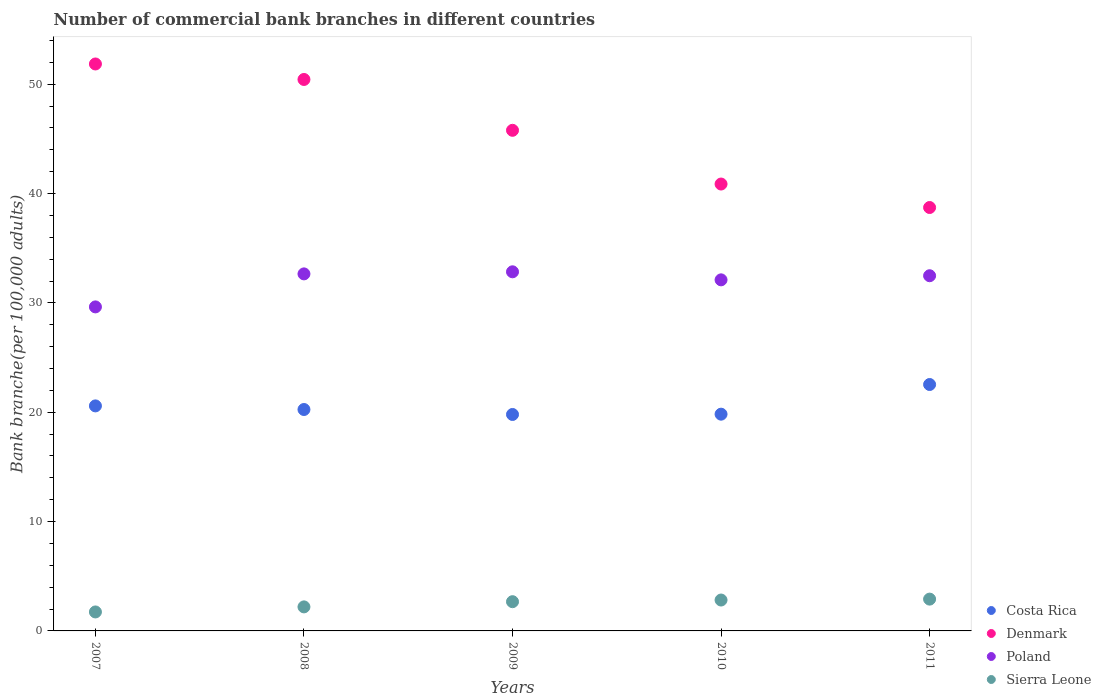What is the number of commercial bank branches in Poland in 2009?
Keep it short and to the point. 32.84. Across all years, what is the maximum number of commercial bank branches in Denmark?
Offer a terse response. 51.85. Across all years, what is the minimum number of commercial bank branches in Costa Rica?
Your answer should be very brief. 19.79. What is the total number of commercial bank branches in Poland in the graph?
Ensure brevity in your answer.  159.71. What is the difference between the number of commercial bank branches in Costa Rica in 2007 and that in 2011?
Offer a terse response. -1.96. What is the difference between the number of commercial bank branches in Denmark in 2008 and the number of commercial bank branches in Poland in 2009?
Give a very brief answer. 17.59. What is the average number of commercial bank branches in Costa Rica per year?
Your answer should be compact. 20.6. In the year 2009, what is the difference between the number of commercial bank branches in Costa Rica and number of commercial bank branches in Denmark?
Provide a short and direct response. -25.99. In how many years, is the number of commercial bank branches in Sierra Leone greater than 52?
Offer a terse response. 0. What is the ratio of the number of commercial bank branches in Poland in 2009 to that in 2010?
Make the answer very short. 1.02. Is the number of commercial bank branches in Costa Rica in 2007 less than that in 2011?
Your answer should be very brief. Yes. Is the difference between the number of commercial bank branches in Costa Rica in 2009 and 2011 greater than the difference between the number of commercial bank branches in Denmark in 2009 and 2011?
Offer a terse response. No. What is the difference between the highest and the second highest number of commercial bank branches in Poland?
Provide a short and direct response. 0.19. What is the difference between the highest and the lowest number of commercial bank branches in Sierra Leone?
Ensure brevity in your answer.  1.17. Is the sum of the number of commercial bank branches in Poland in 2007 and 2011 greater than the maximum number of commercial bank branches in Costa Rica across all years?
Keep it short and to the point. Yes. Is it the case that in every year, the sum of the number of commercial bank branches in Costa Rica and number of commercial bank branches in Sierra Leone  is greater than the sum of number of commercial bank branches in Poland and number of commercial bank branches in Denmark?
Offer a terse response. No. Does the number of commercial bank branches in Denmark monotonically increase over the years?
Give a very brief answer. No. Is the number of commercial bank branches in Poland strictly less than the number of commercial bank branches in Sierra Leone over the years?
Your answer should be very brief. No. How many dotlines are there?
Your answer should be compact. 4. What is the difference between two consecutive major ticks on the Y-axis?
Your answer should be very brief. 10. Are the values on the major ticks of Y-axis written in scientific E-notation?
Keep it short and to the point. No. Does the graph contain any zero values?
Provide a short and direct response. No. Does the graph contain grids?
Ensure brevity in your answer.  No. How are the legend labels stacked?
Ensure brevity in your answer.  Vertical. What is the title of the graph?
Provide a short and direct response. Number of commercial bank branches in different countries. What is the label or title of the X-axis?
Your answer should be very brief. Years. What is the label or title of the Y-axis?
Your answer should be compact. Bank branche(per 100,0 adults). What is the Bank branche(per 100,000 adults) in Costa Rica in 2007?
Ensure brevity in your answer.  20.58. What is the Bank branche(per 100,000 adults) of Denmark in 2007?
Offer a terse response. 51.85. What is the Bank branche(per 100,000 adults) of Poland in 2007?
Provide a succinct answer. 29.63. What is the Bank branche(per 100,000 adults) in Sierra Leone in 2007?
Provide a short and direct response. 1.73. What is the Bank branche(per 100,000 adults) in Costa Rica in 2008?
Make the answer very short. 20.25. What is the Bank branche(per 100,000 adults) in Denmark in 2008?
Offer a very short reply. 50.43. What is the Bank branche(per 100,000 adults) of Poland in 2008?
Give a very brief answer. 32.65. What is the Bank branche(per 100,000 adults) in Sierra Leone in 2008?
Make the answer very short. 2.2. What is the Bank branche(per 100,000 adults) in Costa Rica in 2009?
Offer a very short reply. 19.79. What is the Bank branche(per 100,000 adults) of Denmark in 2009?
Provide a succinct answer. 45.78. What is the Bank branche(per 100,000 adults) in Poland in 2009?
Your answer should be very brief. 32.84. What is the Bank branche(per 100,000 adults) in Sierra Leone in 2009?
Ensure brevity in your answer.  2.67. What is the Bank branche(per 100,000 adults) in Costa Rica in 2010?
Offer a very short reply. 19.82. What is the Bank branche(per 100,000 adults) in Denmark in 2010?
Your answer should be compact. 40.87. What is the Bank branche(per 100,000 adults) of Poland in 2010?
Ensure brevity in your answer.  32.11. What is the Bank branche(per 100,000 adults) of Sierra Leone in 2010?
Your answer should be compact. 2.83. What is the Bank branche(per 100,000 adults) of Costa Rica in 2011?
Make the answer very short. 22.53. What is the Bank branche(per 100,000 adults) of Denmark in 2011?
Keep it short and to the point. 38.72. What is the Bank branche(per 100,000 adults) in Poland in 2011?
Offer a terse response. 32.48. What is the Bank branche(per 100,000 adults) in Sierra Leone in 2011?
Your answer should be compact. 2.91. Across all years, what is the maximum Bank branche(per 100,000 adults) in Costa Rica?
Your response must be concise. 22.53. Across all years, what is the maximum Bank branche(per 100,000 adults) of Denmark?
Your answer should be very brief. 51.85. Across all years, what is the maximum Bank branche(per 100,000 adults) of Poland?
Your answer should be very brief. 32.84. Across all years, what is the maximum Bank branche(per 100,000 adults) in Sierra Leone?
Offer a terse response. 2.91. Across all years, what is the minimum Bank branche(per 100,000 adults) of Costa Rica?
Offer a very short reply. 19.79. Across all years, what is the minimum Bank branche(per 100,000 adults) of Denmark?
Ensure brevity in your answer.  38.72. Across all years, what is the minimum Bank branche(per 100,000 adults) in Poland?
Your response must be concise. 29.63. Across all years, what is the minimum Bank branche(per 100,000 adults) in Sierra Leone?
Provide a succinct answer. 1.73. What is the total Bank branche(per 100,000 adults) in Costa Rica in the graph?
Offer a very short reply. 102.98. What is the total Bank branche(per 100,000 adults) in Denmark in the graph?
Your answer should be compact. 227.65. What is the total Bank branche(per 100,000 adults) in Poland in the graph?
Provide a short and direct response. 159.71. What is the total Bank branche(per 100,000 adults) in Sierra Leone in the graph?
Offer a terse response. 12.34. What is the difference between the Bank branche(per 100,000 adults) in Costa Rica in 2007 and that in 2008?
Keep it short and to the point. 0.33. What is the difference between the Bank branche(per 100,000 adults) in Denmark in 2007 and that in 2008?
Make the answer very short. 1.42. What is the difference between the Bank branche(per 100,000 adults) of Poland in 2007 and that in 2008?
Your response must be concise. -3.02. What is the difference between the Bank branche(per 100,000 adults) in Sierra Leone in 2007 and that in 2008?
Give a very brief answer. -0.46. What is the difference between the Bank branche(per 100,000 adults) in Costa Rica in 2007 and that in 2009?
Your response must be concise. 0.78. What is the difference between the Bank branche(per 100,000 adults) of Denmark in 2007 and that in 2009?
Your answer should be compact. 6.07. What is the difference between the Bank branche(per 100,000 adults) in Poland in 2007 and that in 2009?
Your response must be concise. -3.21. What is the difference between the Bank branche(per 100,000 adults) in Sierra Leone in 2007 and that in 2009?
Your answer should be very brief. -0.94. What is the difference between the Bank branche(per 100,000 adults) in Costa Rica in 2007 and that in 2010?
Give a very brief answer. 0.76. What is the difference between the Bank branche(per 100,000 adults) of Denmark in 2007 and that in 2010?
Make the answer very short. 10.98. What is the difference between the Bank branche(per 100,000 adults) of Poland in 2007 and that in 2010?
Provide a short and direct response. -2.47. What is the difference between the Bank branche(per 100,000 adults) of Sierra Leone in 2007 and that in 2010?
Offer a very short reply. -1.09. What is the difference between the Bank branche(per 100,000 adults) in Costa Rica in 2007 and that in 2011?
Provide a succinct answer. -1.96. What is the difference between the Bank branche(per 100,000 adults) in Denmark in 2007 and that in 2011?
Provide a short and direct response. 13.13. What is the difference between the Bank branche(per 100,000 adults) of Poland in 2007 and that in 2011?
Ensure brevity in your answer.  -2.85. What is the difference between the Bank branche(per 100,000 adults) in Sierra Leone in 2007 and that in 2011?
Keep it short and to the point. -1.17. What is the difference between the Bank branche(per 100,000 adults) of Costa Rica in 2008 and that in 2009?
Your response must be concise. 0.45. What is the difference between the Bank branche(per 100,000 adults) of Denmark in 2008 and that in 2009?
Offer a terse response. 4.65. What is the difference between the Bank branche(per 100,000 adults) of Poland in 2008 and that in 2009?
Your answer should be compact. -0.19. What is the difference between the Bank branche(per 100,000 adults) in Sierra Leone in 2008 and that in 2009?
Keep it short and to the point. -0.48. What is the difference between the Bank branche(per 100,000 adults) of Costa Rica in 2008 and that in 2010?
Provide a short and direct response. 0.43. What is the difference between the Bank branche(per 100,000 adults) in Denmark in 2008 and that in 2010?
Give a very brief answer. 9.56. What is the difference between the Bank branche(per 100,000 adults) in Poland in 2008 and that in 2010?
Your answer should be compact. 0.54. What is the difference between the Bank branche(per 100,000 adults) of Sierra Leone in 2008 and that in 2010?
Make the answer very short. -0.63. What is the difference between the Bank branche(per 100,000 adults) in Costa Rica in 2008 and that in 2011?
Provide a succinct answer. -2.29. What is the difference between the Bank branche(per 100,000 adults) of Denmark in 2008 and that in 2011?
Ensure brevity in your answer.  11.71. What is the difference between the Bank branche(per 100,000 adults) in Poland in 2008 and that in 2011?
Ensure brevity in your answer.  0.17. What is the difference between the Bank branche(per 100,000 adults) of Sierra Leone in 2008 and that in 2011?
Provide a succinct answer. -0.71. What is the difference between the Bank branche(per 100,000 adults) of Costa Rica in 2009 and that in 2010?
Provide a succinct answer. -0.03. What is the difference between the Bank branche(per 100,000 adults) in Denmark in 2009 and that in 2010?
Provide a short and direct response. 4.91. What is the difference between the Bank branche(per 100,000 adults) of Poland in 2009 and that in 2010?
Your answer should be very brief. 0.74. What is the difference between the Bank branche(per 100,000 adults) in Sierra Leone in 2009 and that in 2010?
Offer a very short reply. -0.15. What is the difference between the Bank branche(per 100,000 adults) in Costa Rica in 2009 and that in 2011?
Provide a succinct answer. -2.74. What is the difference between the Bank branche(per 100,000 adults) in Denmark in 2009 and that in 2011?
Make the answer very short. 7.06. What is the difference between the Bank branche(per 100,000 adults) of Poland in 2009 and that in 2011?
Give a very brief answer. 0.36. What is the difference between the Bank branche(per 100,000 adults) in Sierra Leone in 2009 and that in 2011?
Ensure brevity in your answer.  -0.23. What is the difference between the Bank branche(per 100,000 adults) of Costa Rica in 2010 and that in 2011?
Provide a short and direct response. -2.71. What is the difference between the Bank branche(per 100,000 adults) of Denmark in 2010 and that in 2011?
Ensure brevity in your answer.  2.15. What is the difference between the Bank branche(per 100,000 adults) of Poland in 2010 and that in 2011?
Make the answer very short. -0.38. What is the difference between the Bank branche(per 100,000 adults) of Sierra Leone in 2010 and that in 2011?
Your answer should be very brief. -0.08. What is the difference between the Bank branche(per 100,000 adults) in Costa Rica in 2007 and the Bank branche(per 100,000 adults) in Denmark in 2008?
Provide a short and direct response. -29.85. What is the difference between the Bank branche(per 100,000 adults) in Costa Rica in 2007 and the Bank branche(per 100,000 adults) in Poland in 2008?
Your answer should be compact. -12.07. What is the difference between the Bank branche(per 100,000 adults) in Costa Rica in 2007 and the Bank branche(per 100,000 adults) in Sierra Leone in 2008?
Give a very brief answer. 18.38. What is the difference between the Bank branche(per 100,000 adults) in Denmark in 2007 and the Bank branche(per 100,000 adults) in Poland in 2008?
Your response must be concise. 19.2. What is the difference between the Bank branche(per 100,000 adults) of Denmark in 2007 and the Bank branche(per 100,000 adults) of Sierra Leone in 2008?
Keep it short and to the point. 49.65. What is the difference between the Bank branche(per 100,000 adults) in Poland in 2007 and the Bank branche(per 100,000 adults) in Sierra Leone in 2008?
Offer a very short reply. 27.43. What is the difference between the Bank branche(per 100,000 adults) in Costa Rica in 2007 and the Bank branche(per 100,000 adults) in Denmark in 2009?
Make the answer very short. -25.2. What is the difference between the Bank branche(per 100,000 adults) in Costa Rica in 2007 and the Bank branche(per 100,000 adults) in Poland in 2009?
Provide a short and direct response. -12.26. What is the difference between the Bank branche(per 100,000 adults) in Costa Rica in 2007 and the Bank branche(per 100,000 adults) in Sierra Leone in 2009?
Keep it short and to the point. 17.91. What is the difference between the Bank branche(per 100,000 adults) in Denmark in 2007 and the Bank branche(per 100,000 adults) in Poland in 2009?
Ensure brevity in your answer.  19.01. What is the difference between the Bank branche(per 100,000 adults) in Denmark in 2007 and the Bank branche(per 100,000 adults) in Sierra Leone in 2009?
Make the answer very short. 49.18. What is the difference between the Bank branche(per 100,000 adults) of Poland in 2007 and the Bank branche(per 100,000 adults) of Sierra Leone in 2009?
Ensure brevity in your answer.  26.96. What is the difference between the Bank branche(per 100,000 adults) in Costa Rica in 2007 and the Bank branche(per 100,000 adults) in Denmark in 2010?
Provide a short and direct response. -20.29. What is the difference between the Bank branche(per 100,000 adults) in Costa Rica in 2007 and the Bank branche(per 100,000 adults) in Poland in 2010?
Your answer should be very brief. -11.53. What is the difference between the Bank branche(per 100,000 adults) of Costa Rica in 2007 and the Bank branche(per 100,000 adults) of Sierra Leone in 2010?
Your response must be concise. 17.75. What is the difference between the Bank branche(per 100,000 adults) in Denmark in 2007 and the Bank branche(per 100,000 adults) in Poland in 2010?
Your answer should be very brief. 19.74. What is the difference between the Bank branche(per 100,000 adults) of Denmark in 2007 and the Bank branche(per 100,000 adults) of Sierra Leone in 2010?
Provide a short and direct response. 49.02. What is the difference between the Bank branche(per 100,000 adults) of Poland in 2007 and the Bank branche(per 100,000 adults) of Sierra Leone in 2010?
Your response must be concise. 26.81. What is the difference between the Bank branche(per 100,000 adults) in Costa Rica in 2007 and the Bank branche(per 100,000 adults) in Denmark in 2011?
Your answer should be compact. -18.14. What is the difference between the Bank branche(per 100,000 adults) of Costa Rica in 2007 and the Bank branche(per 100,000 adults) of Poland in 2011?
Your response must be concise. -11.9. What is the difference between the Bank branche(per 100,000 adults) of Costa Rica in 2007 and the Bank branche(per 100,000 adults) of Sierra Leone in 2011?
Give a very brief answer. 17.67. What is the difference between the Bank branche(per 100,000 adults) of Denmark in 2007 and the Bank branche(per 100,000 adults) of Poland in 2011?
Make the answer very short. 19.37. What is the difference between the Bank branche(per 100,000 adults) of Denmark in 2007 and the Bank branche(per 100,000 adults) of Sierra Leone in 2011?
Make the answer very short. 48.94. What is the difference between the Bank branche(per 100,000 adults) in Poland in 2007 and the Bank branche(per 100,000 adults) in Sierra Leone in 2011?
Your answer should be very brief. 26.72. What is the difference between the Bank branche(per 100,000 adults) of Costa Rica in 2008 and the Bank branche(per 100,000 adults) of Denmark in 2009?
Your answer should be compact. -25.53. What is the difference between the Bank branche(per 100,000 adults) in Costa Rica in 2008 and the Bank branche(per 100,000 adults) in Poland in 2009?
Provide a succinct answer. -12.59. What is the difference between the Bank branche(per 100,000 adults) of Costa Rica in 2008 and the Bank branche(per 100,000 adults) of Sierra Leone in 2009?
Offer a terse response. 17.58. What is the difference between the Bank branche(per 100,000 adults) of Denmark in 2008 and the Bank branche(per 100,000 adults) of Poland in 2009?
Your answer should be very brief. 17.59. What is the difference between the Bank branche(per 100,000 adults) in Denmark in 2008 and the Bank branche(per 100,000 adults) in Sierra Leone in 2009?
Provide a succinct answer. 47.76. What is the difference between the Bank branche(per 100,000 adults) of Poland in 2008 and the Bank branche(per 100,000 adults) of Sierra Leone in 2009?
Offer a terse response. 29.98. What is the difference between the Bank branche(per 100,000 adults) in Costa Rica in 2008 and the Bank branche(per 100,000 adults) in Denmark in 2010?
Provide a short and direct response. -20.62. What is the difference between the Bank branche(per 100,000 adults) in Costa Rica in 2008 and the Bank branche(per 100,000 adults) in Poland in 2010?
Make the answer very short. -11.86. What is the difference between the Bank branche(per 100,000 adults) in Costa Rica in 2008 and the Bank branche(per 100,000 adults) in Sierra Leone in 2010?
Make the answer very short. 17.42. What is the difference between the Bank branche(per 100,000 adults) in Denmark in 2008 and the Bank branche(per 100,000 adults) in Poland in 2010?
Offer a terse response. 18.33. What is the difference between the Bank branche(per 100,000 adults) in Denmark in 2008 and the Bank branche(per 100,000 adults) in Sierra Leone in 2010?
Your answer should be very brief. 47.61. What is the difference between the Bank branche(per 100,000 adults) in Poland in 2008 and the Bank branche(per 100,000 adults) in Sierra Leone in 2010?
Offer a terse response. 29.83. What is the difference between the Bank branche(per 100,000 adults) in Costa Rica in 2008 and the Bank branche(per 100,000 adults) in Denmark in 2011?
Provide a short and direct response. -18.47. What is the difference between the Bank branche(per 100,000 adults) in Costa Rica in 2008 and the Bank branche(per 100,000 adults) in Poland in 2011?
Provide a short and direct response. -12.23. What is the difference between the Bank branche(per 100,000 adults) of Costa Rica in 2008 and the Bank branche(per 100,000 adults) of Sierra Leone in 2011?
Provide a short and direct response. 17.34. What is the difference between the Bank branche(per 100,000 adults) in Denmark in 2008 and the Bank branche(per 100,000 adults) in Poland in 2011?
Provide a succinct answer. 17.95. What is the difference between the Bank branche(per 100,000 adults) of Denmark in 2008 and the Bank branche(per 100,000 adults) of Sierra Leone in 2011?
Offer a terse response. 47.52. What is the difference between the Bank branche(per 100,000 adults) of Poland in 2008 and the Bank branche(per 100,000 adults) of Sierra Leone in 2011?
Ensure brevity in your answer.  29.74. What is the difference between the Bank branche(per 100,000 adults) in Costa Rica in 2009 and the Bank branche(per 100,000 adults) in Denmark in 2010?
Keep it short and to the point. -21.07. What is the difference between the Bank branche(per 100,000 adults) in Costa Rica in 2009 and the Bank branche(per 100,000 adults) in Poland in 2010?
Offer a terse response. -12.31. What is the difference between the Bank branche(per 100,000 adults) in Costa Rica in 2009 and the Bank branche(per 100,000 adults) in Sierra Leone in 2010?
Ensure brevity in your answer.  16.97. What is the difference between the Bank branche(per 100,000 adults) in Denmark in 2009 and the Bank branche(per 100,000 adults) in Poland in 2010?
Make the answer very short. 13.68. What is the difference between the Bank branche(per 100,000 adults) in Denmark in 2009 and the Bank branche(per 100,000 adults) in Sierra Leone in 2010?
Your answer should be very brief. 42.96. What is the difference between the Bank branche(per 100,000 adults) of Poland in 2009 and the Bank branche(per 100,000 adults) of Sierra Leone in 2010?
Provide a short and direct response. 30.02. What is the difference between the Bank branche(per 100,000 adults) of Costa Rica in 2009 and the Bank branche(per 100,000 adults) of Denmark in 2011?
Your answer should be compact. -18.93. What is the difference between the Bank branche(per 100,000 adults) in Costa Rica in 2009 and the Bank branche(per 100,000 adults) in Poland in 2011?
Your answer should be compact. -12.69. What is the difference between the Bank branche(per 100,000 adults) in Costa Rica in 2009 and the Bank branche(per 100,000 adults) in Sierra Leone in 2011?
Provide a succinct answer. 16.89. What is the difference between the Bank branche(per 100,000 adults) of Denmark in 2009 and the Bank branche(per 100,000 adults) of Poland in 2011?
Offer a terse response. 13.3. What is the difference between the Bank branche(per 100,000 adults) of Denmark in 2009 and the Bank branche(per 100,000 adults) of Sierra Leone in 2011?
Provide a succinct answer. 42.87. What is the difference between the Bank branche(per 100,000 adults) of Poland in 2009 and the Bank branche(per 100,000 adults) of Sierra Leone in 2011?
Offer a very short reply. 29.93. What is the difference between the Bank branche(per 100,000 adults) of Costa Rica in 2010 and the Bank branche(per 100,000 adults) of Denmark in 2011?
Give a very brief answer. -18.9. What is the difference between the Bank branche(per 100,000 adults) of Costa Rica in 2010 and the Bank branche(per 100,000 adults) of Poland in 2011?
Your response must be concise. -12.66. What is the difference between the Bank branche(per 100,000 adults) of Costa Rica in 2010 and the Bank branche(per 100,000 adults) of Sierra Leone in 2011?
Provide a short and direct response. 16.91. What is the difference between the Bank branche(per 100,000 adults) of Denmark in 2010 and the Bank branche(per 100,000 adults) of Poland in 2011?
Ensure brevity in your answer.  8.39. What is the difference between the Bank branche(per 100,000 adults) of Denmark in 2010 and the Bank branche(per 100,000 adults) of Sierra Leone in 2011?
Your answer should be compact. 37.96. What is the difference between the Bank branche(per 100,000 adults) in Poland in 2010 and the Bank branche(per 100,000 adults) in Sierra Leone in 2011?
Offer a terse response. 29.2. What is the average Bank branche(per 100,000 adults) of Costa Rica per year?
Provide a short and direct response. 20.6. What is the average Bank branche(per 100,000 adults) of Denmark per year?
Make the answer very short. 45.53. What is the average Bank branche(per 100,000 adults) in Poland per year?
Make the answer very short. 31.94. What is the average Bank branche(per 100,000 adults) of Sierra Leone per year?
Provide a short and direct response. 2.47. In the year 2007, what is the difference between the Bank branche(per 100,000 adults) in Costa Rica and Bank branche(per 100,000 adults) in Denmark?
Provide a short and direct response. -31.27. In the year 2007, what is the difference between the Bank branche(per 100,000 adults) in Costa Rica and Bank branche(per 100,000 adults) in Poland?
Ensure brevity in your answer.  -9.05. In the year 2007, what is the difference between the Bank branche(per 100,000 adults) of Costa Rica and Bank branche(per 100,000 adults) of Sierra Leone?
Provide a succinct answer. 18.84. In the year 2007, what is the difference between the Bank branche(per 100,000 adults) in Denmark and Bank branche(per 100,000 adults) in Poland?
Your response must be concise. 22.22. In the year 2007, what is the difference between the Bank branche(per 100,000 adults) in Denmark and Bank branche(per 100,000 adults) in Sierra Leone?
Offer a very short reply. 50.11. In the year 2007, what is the difference between the Bank branche(per 100,000 adults) of Poland and Bank branche(per 100,000 adults) of Sierra Leone?
Provide a succinct answer. 27.9. In the year 2008, what is the difference between the Bank branche(per 100,000 adults) of Costa Rica and Bank branche(per 100,000 adults) of Denmark?
Offer a very short reply. -30.18. In the year 2008, what is the difference between the Bank branche(per 100,000 adults) of Costa Rica and Bank branche(per 100,000 adults) of Poland?
Provide a succinct answer. -12.4. In the year 2008, what is the difference between the Bank branche(per 100,000 adults) in Costa Rica and Bank branche(per 100,000 adults) in Sierra Leone?
Keep it short and to the point. 18.05. In the year 2008, what is the difference between the Bank branche(per 100,000 adults) of Denmark and Bank branche(per 100,000 adults) of Poland?
Offer a very short reply. 17.78. In the year 2008, what is the difference between the Bank branche(per 100,000 adults) in Denmark and Bank branche(per 100,000 adults) in Sierra Leone?
Keep it short and to the point. 48.23. In the year 2008, what is the difference between the Bank branche(per 100,000 adults) of Poland and Bank branche(per 100,000 adults) of Sierra Leone?
Give a very brief answer. 30.45. In the year 2009, what is the difference between the Bank branche(per 100,000 adults) of Costa Rica and Bank branche(per 100,000 adults) of Denmark?
Give a very brief answer. -25.99. In the year 2009, what is the difference between the Bank branche(per 100,000 adults) of Costa Rica and Bank branche(per 100,000 adults) of Poland?
Ensure brevity in your answer.  -13.05. In the year 2009, what is the difference between the Bank branche(per 100,000 adults) in Costa Rica and Bank branche(per 100,000 adults) in Sierra Leone?
Keep it short and to the point. 17.12. In the year 2009, what is the difference between the Bank branche(per 100,000 adults) of Denmark and Bank branche(per 100,000 adults) of Poland?
Keep it short and to the point. 12.94. In the year 2009, what is the difference between the Bank branche(per 100,000 adults) of Denmark and Bank branche(per 100,000 adults) of Sierra Leone?
Make the answer very short. 43.11. In the year 2009, what is the difference between the Bank branche(per 100,000 adults) in Poland and Bank branche(per 100,000 adults) in Sierra Leone?
Keep it short and to the point. 30.17. In the year 2010, what is the difference between the Bank branche(per 100,000 adults) in Costa Rica and Bank branche(per 100,000 adults) in Denmark?
Offer a very short reply. -21.05. In the year 2010, what is the difference between the Bank branche(per 100,000 adults) in Costa Rica and Bank branche(per 100,000 adults) in Poland?
Provide a succinct answer. -12.28. In the year 2010, what is the difference between the Bank branche(per 100,000 adults) of Costa Rica and Bank branche(per 100,000 adults) of Sierra Leone?
Your answer should be compact. 17. In the year 2010, what is the difference between the Bank branche(per 100,000 adults) in Denmark and Bank branche(per 100,000 adults) in Poland?
Keep it short and to the point. 8.76. In the year 2010, what is the difference between the Bank branche(per 100,000 adults) of Denmark and Bank branche(per 100,000 adults) of Sierra Leone?
Your response must be concise. 38.04. In the year 2010, what is the difference between the Bank branche(per 100,000 adults) of Poland and Bank branche(per 100,000 adults) of Sierra Leone?
Your answer should be very brief. 29.28. In the year 2011, what is the difference between the Bank branche(per 100,000 adults) in Costa Rica and Bank branche(per 100,000 adults) in Denmark?
Provide a succinct answer. -16.19. In the year 2011, what is the difference between the Bank branche(per 100,000 adults) of Costa Rica and Bank branche(per 100,000 adults) of Poland?
Give a very brief answer. -9.95. In the year 2011, what is the difference between the Bank branche(per 100,000 adults) of Costa Rica and Bank branche(per 100,000 adults) of Sierra Leone?
Keep it short and to the point. 19.63. In the year 2011, what is the difference between the Bank branche(per 100,000 adults) of Denmark and Bank branche(per 100,000 adults) of Poland?
Offer a terse response. 6.24. In the year 2011, what is the difference between the Bank branche(per 100,000 adults) in Denmark and Bank branche(per 100,000 adults) in Sierra Leone?
Your answer should be very brief. 35.81. In the year 2011, what is the difference between the Bank branche(per 100,000 adults) of Poland and Bank branche(per 100,000 adults) of Sierra Leone?
Give a very brief answer. 29.57. What is the ratio of the Bank branche(per 100,000 adults) of Costa Rica in 2007 to that in 2008?
Make the answer very short. 1.02. What is the ratio of the Bank branche(per 100,000 adults) of Denmark in 2007 to that in 2008?
Ensure brevity in your answer.  1.03. What is the ratio of the Bank branche(per 100,000 adults) of Poland in 2007 to that in 2008?
Provide a short and direct response. 0.91. What is the ratio of the Bank branche(per 100,000 adults) in Sierra Leone in 2007 to that in 2008?
Offer a very short reply. 0.79. What is the ratio of the Bank branche(per 100,000 adults) in Costa Rica in 2007 to that in 2009?
Give a very brief answer. 1.04. What is the ratio of the Bank branche(per 100,000 adults) of Denmark in 2007 to that in 2009?
Give a very brief answer. 1.13. What is the ratio of the Bank branche(per 100,000 adults) in Poland in 2007 to that in 2009?
Give a very brief answer. 0.9. What is the ratio of the Bank branche(per 100,000 adults) of Sierra Leone in 2007 to that in 2009?
Make the answer very short. 0.65. What is the ratio of the Bank branche(per 100,000 adults) in Costa Rica in 2007 to that in 2010?
Your answer should be very brief. 1.04. What is the ratio of the Bank branche(per 100,000 adults) of Denmark in 2007 to that in 2010?
Offer a very short reply. 1.27. What is the ratio of the Bank branche(per 100,000 adults) in Poland in 2007 to that in 2010?
Your answer should be very brief. 0.92. What is the ratio of the Bank branche(per 100,000 adults) in Sierra Leone in 2007 to that in 2010?
Offer a very short reply. 0.61. What is the ratio of the Bank branche(per 100,000 adults) of Costa Rica in 2007 to that in 2011?
Your answer should be compact. 0.91. What is the ratio of the Bank branche(per 100,000 adults) of Denmark in 2007 to that in 2011?
Your answer should be compact. 1.34. What is the ratio of the Bank branche(per 100,000 adults) of Poland in 2007 to that in 2011?
Your answer should be compact. 0.91. What is the ratio of the Bank branche(per 100,000 adults) of Sierra Leone in 2007 to that in 2011?
Give a very brief answer. 0.6. What is the ratio of the Bank branche(per 100,000 adults) in Denmark in 2008 to that in 2009?
Offer a very short reply. 1.1. What is the ratio of the Bank branche(per 100,000 adults) of Poland in 2008 to that in 2009?
Ensure brevity in your answer.  0.99. What is the ratio of the Bank branche(per 100,000 adults) of Sierra Leone in 2008 to that in 2009?
Keep it short and to the point. 0.82. What is the ratio of the Bank branche(per 100,000 adults) in Costa Rica in 2008 to that in 2010?
Give a very brief answer. 1.02. What is the ratio of the Bank branche(per 100,000 adults) in Denmark in 2008 to that in 2010?
Your response must be concise. 1.23. What is the ratio of the Bank branche(per 100,000 adults) of Sierra Leone in 2008 to that in 2010?
Provide a short and direct response. 0.78. What is the ratio of the Bank branche(per 100,000 adults) of Costa Rica in 2008 to that in 2011?
Your answer should be very brief. 0.9. What is the ratio of the Bank branche(per 100,000 adults) in Denmark in 2008 to that in 2011?
Offer a very short reply. 1.3. What is the ratio of the Bank branche(per 100,000 adults) of Poland in 2008 to that in 2011?
Provide a short and direct response. 1.01. What is the ratio of the Bank branche(per 100,000 adults) of Sierra Leone in 2008 to that in 2011?
Your answer should be very brief. 0.76. What is the ratio of the Bank branche(per 100,000 adults) of Costa Rica in 2009 to that in 2010?
Offer a very short reply. 1. What is the ratio of the Bank branche(per 100,000 adults) in Denmark in 2009 to that in 2010?
Make the answer very short. 1.12. What is the ratio of the Bank branche(per 100,000 adults) of Poland in 2009 to that in 2010?
Make the answer very short. 1.02. What is the ratio of the Bank branche(per 100,000 adults) in Sierra Leone in 2009 to that in 2010?
Ensure brevity in your answer.  0.95. What is the ratio of the Bank branche(per 100,000 adults) of Costa Rica in 2009 to that in 2011?
Your answer should be very brief. 0.88. What is the ratio of the Bank branche(per 100,000 adults) of Denmark in 2009 to that in 2011?
Make the answer very short. 1.18. What is the ratio of the Bank branche(per 100,000 adults) in Poland in 2009 to that in 2011?
Offer a very short reply. 1.01. What is the ratio of the Bank branche(per 100,000 adults) of Sierra Leone in 2009 to that in 2011?
Provide a succinct answer. 0.92. What is the ratio of the Bank branche(per 100,000 adults) of Costa Rica in 2010 to that in 2011?
Give a very brief answer. 0.88. What is the ratio of the Bank branche(per 100,000 adults) in Denmark in 2010 to that in 2011?
Provide a short and direct response. 1.06. What is the ratio of the Bank branche(per 100,000 adults) in Poland in 2010 to that in 2011?
Your answer should be compact. 0.99. What is the ratio of the Bank branche(per 100,000 adults) in Sierra Leone in 2010 to that in 2011?
Make the answer very short. 0.97. What is the difference between the highest and the second highest Bank branche(per 100,000 adults) in Costa Rica?
Ensure brevity in your answer.  1.96. What is the difference between the highest and the second highest Bank branche(per 100,000 adults) in Denmark?
Offer a terse response. 1.42. What is the difference between the highest and the second highest Bank branche(per 100,000 adults) in Poland?
Provide a short and direct response. 0.19. What is the difference between the highest and the second highest Bank branche(per 100,000 adults) in Sierra Leone?
Make the answer very short. 0.08. What is the difference between the highest and the lowest Bank branche(per 100,000 adults) of Costa Rica?
Your answer should be very brief. 2.74. What is the difference between the highest and the lowest Bank branche(per 100,000 adults) of Denmark?
Ensure brevity in your answer.  13.13. What is the difference between the highest and the lowest Bank branche(per 100,000 adults) in Poland?
Your answer should be very brief. 3.21. What is the difference between the highest and the lowest Bank branche(per 100,000 adults) in Sierra Leone?
Keep it short and to the point. 1.17. 